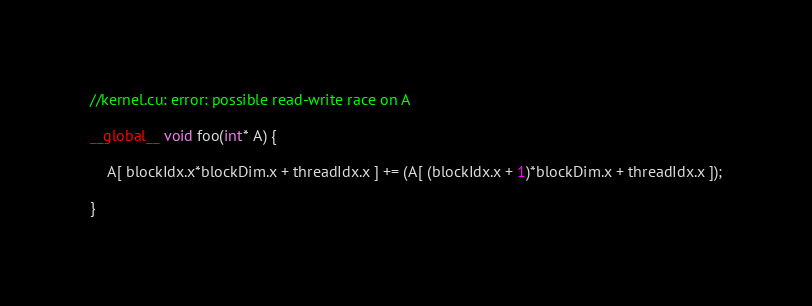Convert code to text. <code><loc_0><loc_0><loc_500><loc_500><_Cuda_>//kernel.cu: error: possible read-write race on A

__global__ void foo(int* A) {

    A[ blockIdx.x*blockDim.x + threadIdx.x ] += (A[ (blockIdx.x + 1)*blockDim.x + threadIdx.x ]);

}
</code> 